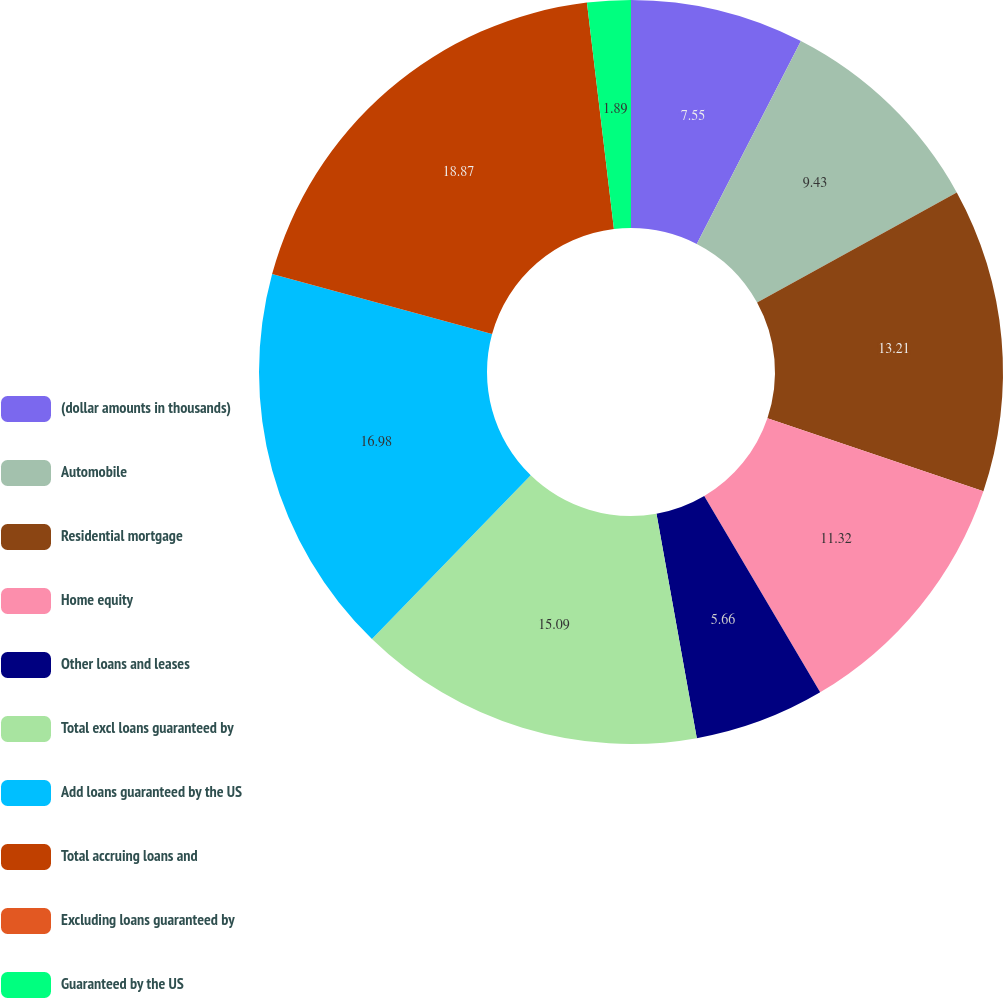Convert chart to OTSL. <chart><loc_0><loc_0><loc_500><loc_500><pie_chart><fcel>(dollar amounts in thousands)<fcel>Automobile<fcel>Residential mortgage<fcel>Home equity<fcel>Other loans and leases<fcel>Total excl loans guaranteed by<fcel>Add loans guaranteed by the US<fcel>Total accruing loans and<fcel>Excluding loans guaranteed by<fcel>Guaranteed by the US<nl><fcel>7.55%<fcel>9.43%<fcel>13.21%<fcel>11.32%<fcel>5.66%<fcel>15.09%<fcel>16.98%<fcel>18.87%<fcel>0.0%<fcel>1.89%<nl></chart> 